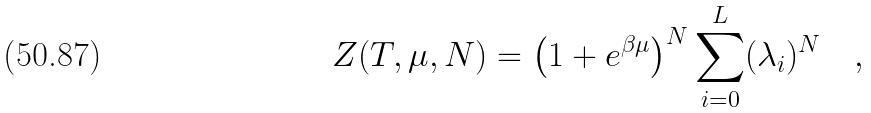Convert formula to latex. <formula><loc_0><loc_0><loc_500><loc_500>Z ( T , \mu , N ) = \left ( 1 + e ^ { \beta \mu } \right ) ^ { N } \sum _ { i = 0 } ^ { L } ( \lambda _ { i } ) ^ { N } \quad ,</formula> 